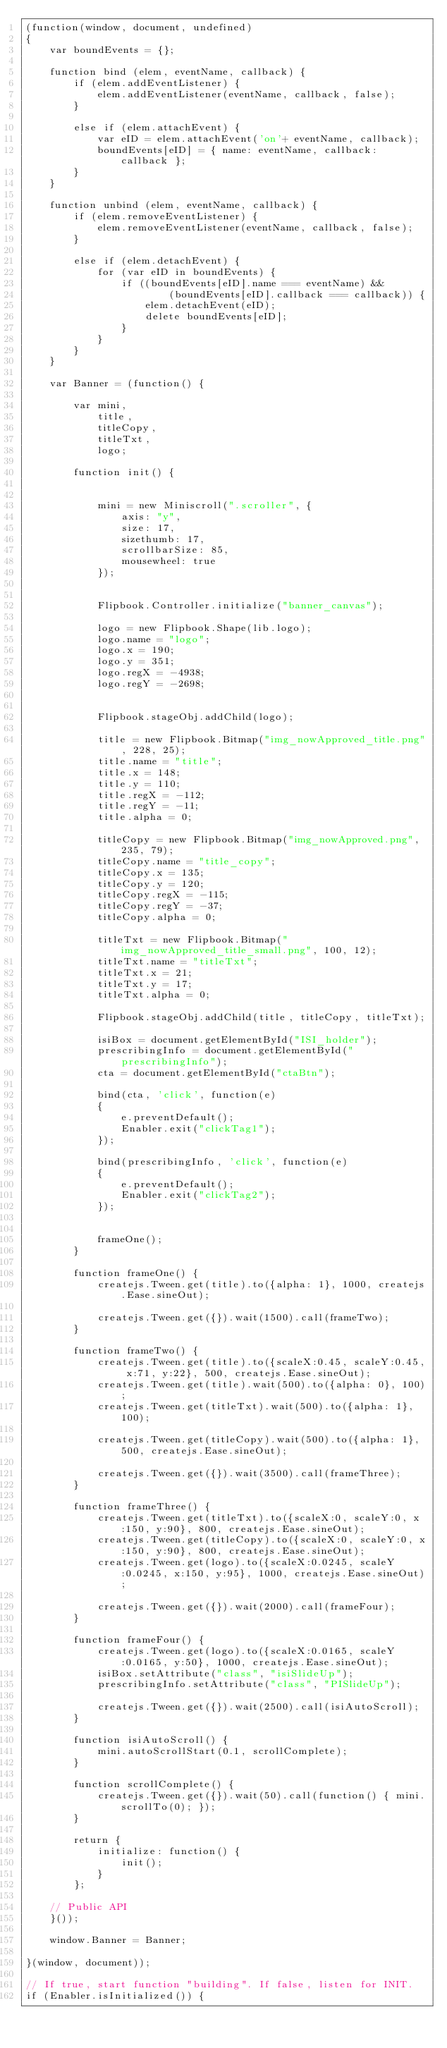<code> <loc_0><loc_0><loc_500><loc_500><_JavaScript_>(function(window, document, undefined)
{
    var boundEvents = {};

    function bind (elem, eventName, callback) {
        if (elem.addEventListener) {
            elem.addEventListener(eventName, callback, false);
        }

        else if (elem.attachEvent) {
            var eID = elem.attachEvent('on'+ eventName, callback);
            boundEvents[eID] = { name: eventName, callback: callback };
        }
    }

    function unbind (elem, eventName, callback) {
        if (elem.removeEventListener) {
            elem.removeEventListener(eventName, callback, false);
        }

        else if (elem.detachEvent) {
            for (var eID in boundEvents) {
                if ((boundEvents[eID].name === eventName) &&
                        (boundEvents[eID].callback === callback)) {
                    elem.detachEvent(eID);
                    delete boundEvents[eID];
                }
            }
        }
    }
    
    var Banner = (function() {

        var mini,
            title,
            titleCopy,
            titleTxt,
            logo;

        function init() {
            
            
            mini = new Miniscroll(".scroller", {
                axis: "y",
                size: 17,
                sizethumb: 17,
                scrollbarSize: 85,
                mousewheel: true
            });


            Flipbook.Controller.initialize("banner_canvas");

            logo = new Flipbook.Shape(lib.logo);
            logo.name = "logo";
            logo.x = 190;
            logo.y = 351;
            logo.regX = -4938;
            logo.regY = -2698;


            Flipbook.stageObj.addChild(logo);
            
            title = new Flipbook.Bitmap("img_nowApproved_title.png", 228, 25);
            title.name = "title";
            title.x = 148;
            title.y = 110;
            title.regX = -112;
            title.regY = -11;
            title.alpha = 0;

            titleCopy = new Flipbook.Bitmap("img_nowApproved.png", 235, 79);
            titleCopy.name = "title_copy";
            titleCopy.x = 135;
            titleCopy.y = 120;
            titleCopy.regX = -115;
            titleCopy.regY = -37;
            titleCopy.alpha = 0;

            titleTxt = new Flipbook.Bitmap("img_nowApproved_title_small.png", 100, 12);
            titleTxt.name = "titleTxt";
            titleTxt.x = 21;
            titleTxt.y = 17;
            titleTxt.alpha = 0;

            Flipbook.stageObj.addChild(title, titleCopy, titleTxt);

            isiBox = document.getElementById("ISI_holder");
            prescribingInfo = document.getElementById("prescribingInfo");
            cta = document.getElementById("ctaBtn");

            bind(cta, 'click', function(e)
            {
                e.preventDefault();
                Enabler.exit("clickTag1");
            });
            
            bind(prescribingInfo, 'click', function(e)
            {
                e.preventDefault();
                Enabler.exit("clickTag2");
            });


            frameOne();
        }

        function frameOne() {
            createjs.Tween.get(title).to({alpha: 1}, 1000, createjs.Ease.sineOut);

            createjs.Tween.get({}).wait(1500).call(frameTwo);
        }

        function frameTwo() {
            createjs.Tween.get(title).to({scaleX:0.45, scaleY:0.45, x:71, y:22}, 500, createjs.Ease.sineOut);
            createjs.Tween.get(title).wait(500).to({alpha: 0}, 100);
            createjs.Tween.get(titleTxt).wait(500).to({alpha: 1}, 100);

            createjs.Tween.get(titleCopy).wait(500).to({alpha: 1}, 500, createjs.Ease.sineOut);
            
            createjs.Tween.get({}).wait(3500).call(frameThree);
        }

        function frameThree() {
            createjs.Tween.get(titleTxt).to({scaleX:0, scaleY:0, x:150, y:90}, 800, createjs.Ease.sineOut);
            createjs.Tween.get(titleCopy).to({scaleX:0, scaleY:0, x:150, y:90}, 800, createjs.Ease.sineOut);
            createjs.Tween.get(logo).to({scaleX:0.0245, scaleY:0.0245, x:150, y:95}, 1000, createjs.Ease.sineOut);
           
            createjs.Tween.get({}).wait(2000).call(frameFour);
        }

        function frameFour() {
            createjs.Tween.get(logo).to({scaleX:0.0165, scaleY:0.0165, y:50}, 1000, createjs.Ease.sineOut);
            isiBox.setAttribute("class", "isiSlideUp");
            prescribingInfo.setAttribute("class", "PISlideUp");

            createjs.Tween.get({}).wait(2500).call(isiAutoScroll);
        }

        function isiAutoScroll() {
            mini.autoScrollStart(0.1, scrollComplete);
        }

        function scrollComplete() {
            createjs.Tween.get({}).wait(50).call(function() { mini.scrollTo(0); });
        }

        return {
            initialize: function() {
                init();
            }
        };

    // Public API
    }());
    
    window.Banner = Banner;

}(window, document));

// If true, start function "building". If false, listen for INIT.
if (Enabler.isInitialized()) {</code> 